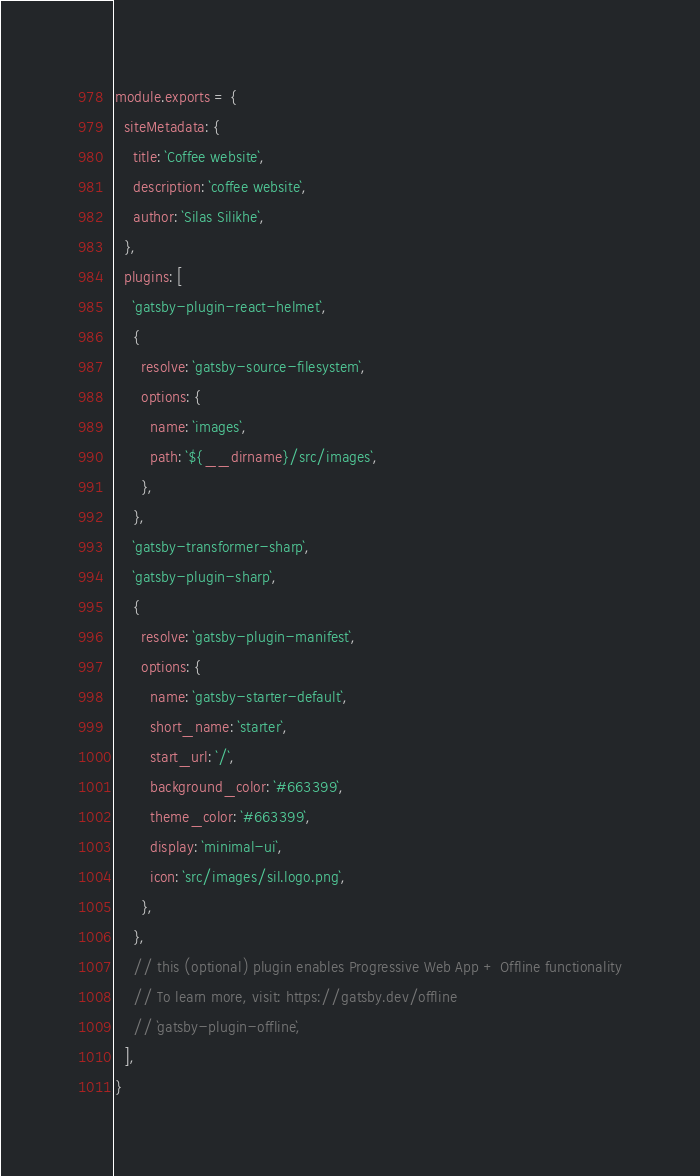<code> <loc_0><loc_0><loc_500><loc_500><_JavaScript_>module.exports = {
  siteMetadata: {
    title: `Coffee website`,
    description: `coffee website`,
    author: `Silas Silikhe`,
  },
  plugins: [
    `gatsby-plugin-react-helmet`,
    {
      resolve: `gatsby-source-filesystem`,
      options: {
        name: `images`,
        path: `${__dirname}/src/images`,
      },
    },
    `gatsby-transformer-sharp`,
    `gatsby-plugin-sharp`,
    {
      resolve: `gatsby-plugin-manifest`,
      options: {
        name: `gatsby-starter-default`,
        short_name: `starter`,
        start_url: `/`,
        background_color: `#663399`,
        theme_color: `#663399`,
        display: `minimal-ui`,
        icon: `src/images/sil.logo.png`,
      },
    },
    // this (optional) plugin enables Progressive Web App + Offline functionality
    // To learn more, visit: https://gatsby.dev/offline
    // `gatsby-plugin-offline`,
  ],
}
</code> 